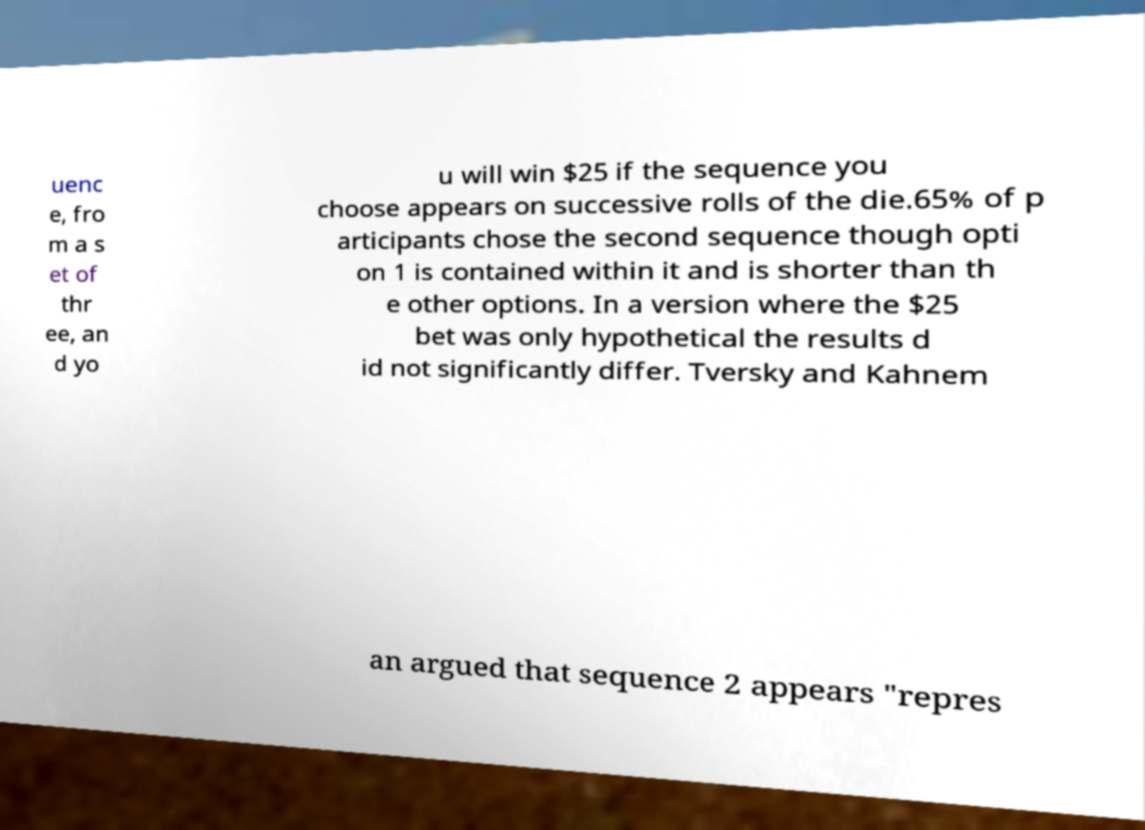Please identify and transcribe the text found in this image. uenc e, fro m a s et of thr ee, an d yo u will win $25 if the sequence you choose appears on successive rolls of the die.65% of p articipants chose the second sequence though opti on 1 is contained within it and is shorter than th e other options. In a version where the $25 bet was only hypothetical the results d id not significantly differ. Tversky and Kahnem an argued that sequence 2 appears "repres 